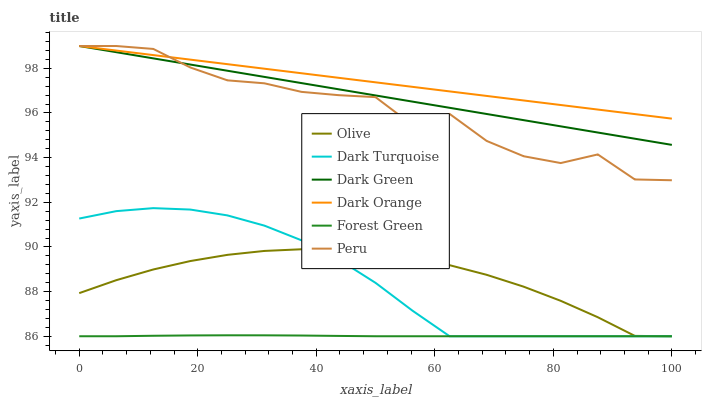Does Dark Turquoise have the minimum area under the curve?
Answer yes or no. No. Does Dark Turquoise have the maximum area under the curve?
Answer yes or no. No. Is Dark Turquoise the smoothest?
Answer yes or no. No. Is Dark Turquoise the roughest?
Answer yes or no. No. Does Peru have the lowest value?
Answer yes or no. No. Does Dark Turquoise have the highest value?
Answer yes or no. No. Is Forest Green less than Dark Orange?
Answer yes or no. Yes. Is Dark Orange greater than Olive?
Answer yes or no. Yes. Does Forest Green intersect Dark Orange?
Answer yes or no. No. 